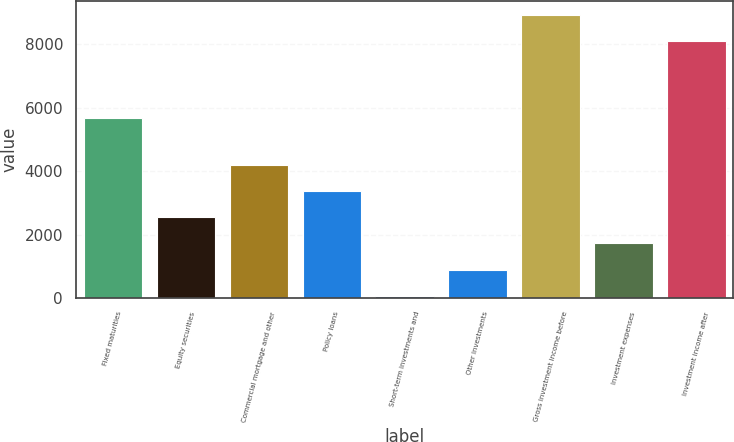<chart> <loc_0><loc_0><loc_500><loc_500><bar_chart><fcel>Fixed maturities<fcel>Equity securities<fcel>Commercial mortgage and other<fcel>Policy loans<fcel>Short-term investments and<fcel>Other investments<fcel>Gross investment income before<fcel>Investment expenses<fcel>Investment income after<nl><fcel>5691<fcel>2543.7<fcel>4195.5<fcel>3369.6<fcel>66<fcel>891.9<fcel>8932.9<fcel>1717.8<fcel>8107<nl></chart> 